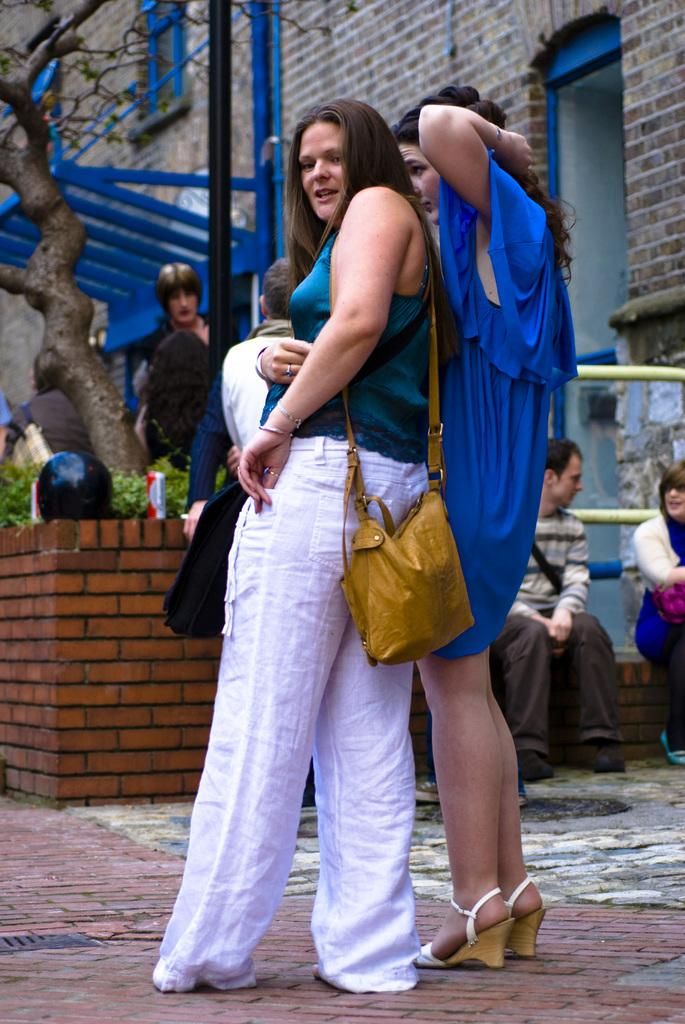What are the people in the image doing? The people in the image are standing. Can you describe the seating arrangement of the two persons in the image? There are two persons sitting on a wall in the image. What type of vegetation can be seen in the image? There are plants and a tree in the image. What is visible in the background of the image? There is a building in the background of the image. What type of pencil can be seen in the image? There is no pencil present in the image. Can you hear the sound of thunder in the image? There is no sound or indication of thunder in the image. 